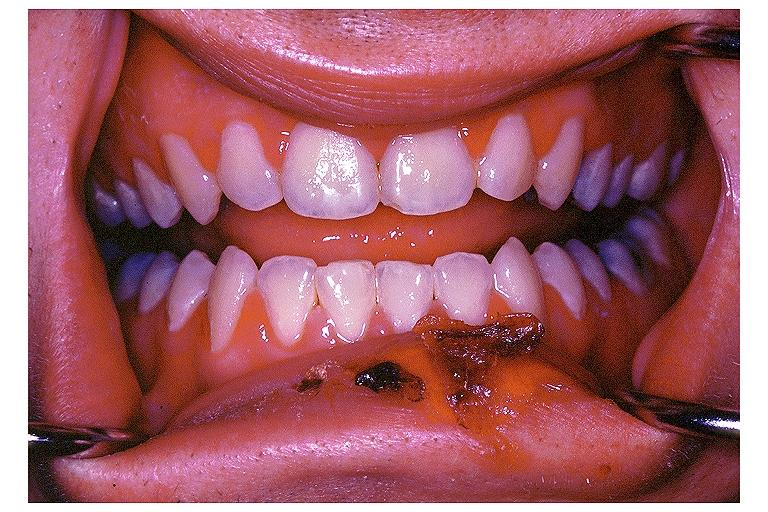s atherosclerosis present?
Answer the question using a single word or phrase. No 